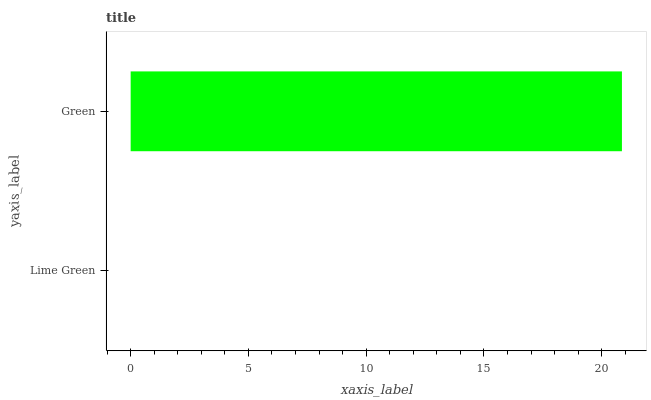Is Lime Green the minimum?
Answer yes or no. Yes. Is Green the maximum?
Answer yes or no. Yes. Is Green the minimum?
Answer yes or no. No. Is Green greater than Lime Green?
Answer yes or no. Yes. Is Lime Green less than Green?
Answer yes or no. Yes. Is Lime Green greater than Green?
Answer yes or no. No. Is Green less than Lime Green?
Answer yes or no. No. Is Green the high median?
Answer yes or no. Yes. Is Lime Green the low median?
Answer yes or no. Yes. Is Lime Green the high median?
Answer yes or no. No. Is Green the low median?
Answer yes or no. No. 